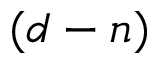Convert formula to latex. <formula><loc_0><loc_0><loc_500><loc_500>( d - n )</formula> 